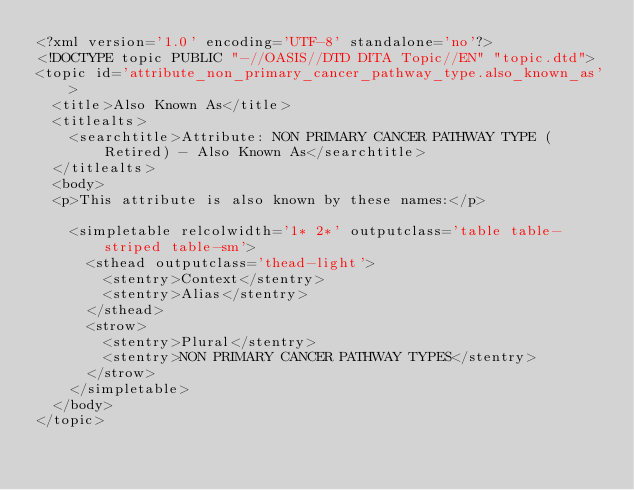Convert code to text. <code><loc_0><loc_0><loc_500><loc_500><_XML_><?xml version='1.0' encoding='UTF-8' standalone='no'?>
<!DOCTYPE topic PUBLIC "-//OASIS//DTD DITA Topic//EN" "topic.dtd">
<topic id='attribute_non_primary_cancer_pathway_type.also_known_as'>
  <title>Also Known As</title>
  <titlealts>
    <searchtitle>Attribute: NON PRIMARY CANCER PATHWAY TYPE (Retired) - Also Known As</searchtitle>
  </titlealts>
  <body>
  <p>This attribute is also known by these names:</p>

    <simpletable relcolwidth='1* 2*' outputclass='table table-striped table-sm'>
      <sthead outputclass='thead-light'>
        <stentry>Context</stentry>
        <stentry>Alias</stentry>
      </sthead>
      <strow>
        <stentry>Plural</stentry>
        <stentry>NON PRIMARY CANCER PATHWAY TYPES</stentry>
      </strow>
    </simpletable>
  </body>
</topic></code> 